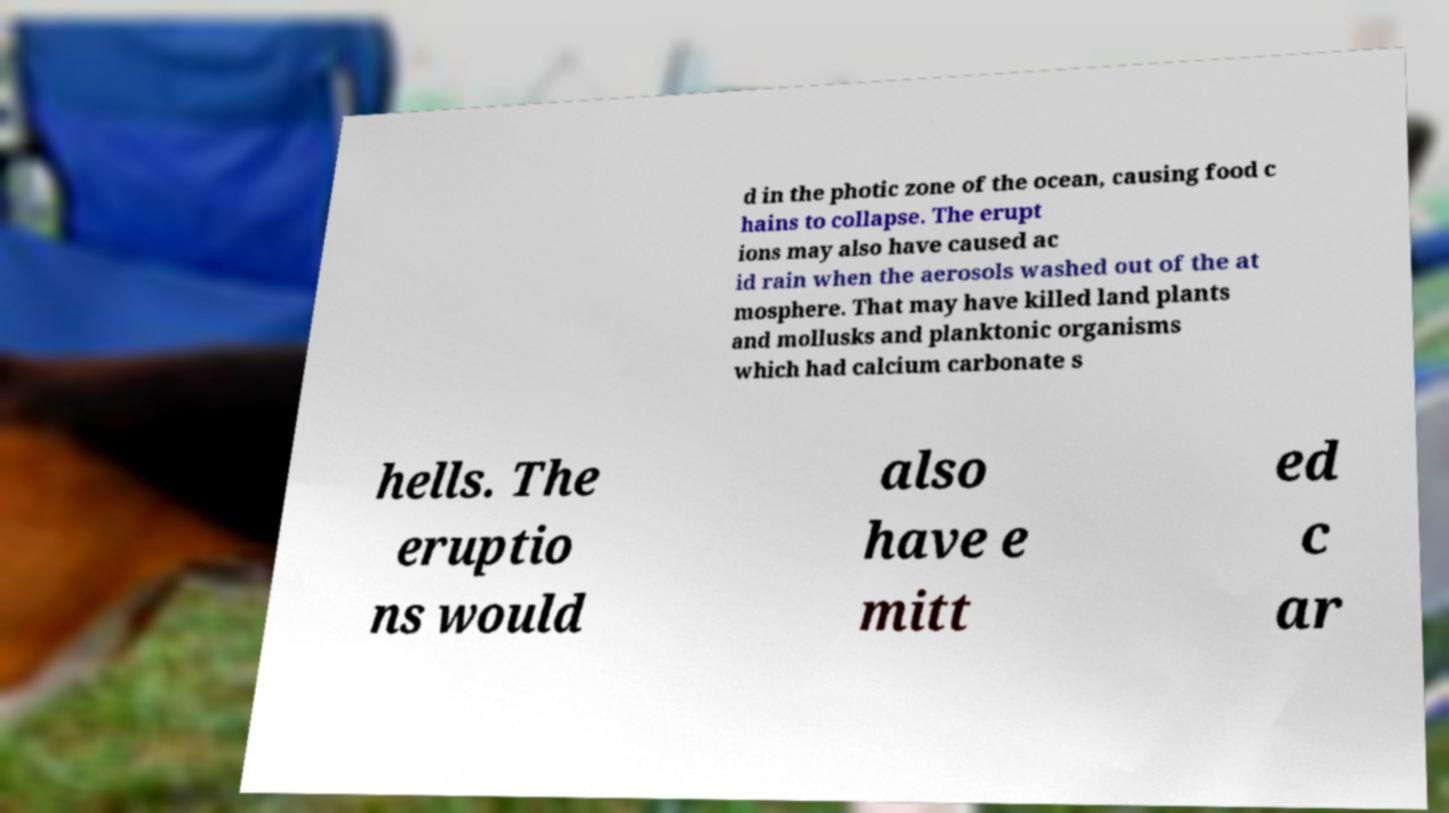Can you accurately transcribe the text from the provided image for me? d in the photic zone of the ocean, causing food c hains to collapse. The erupt ions may also have caused ac id rain when the aerosols washed out of the at mosphere. That may have killed land plants and mollusks and planktonic organisms which had calcium carbonate s hells. The eruptio ns would also have e mitt ed c ar 